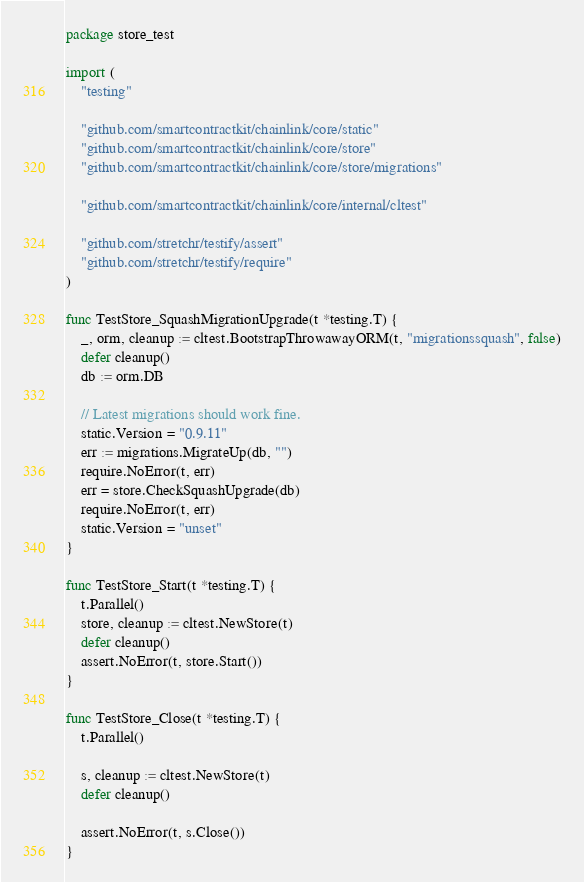Convert code to text. <code><loc_0><loc_0><loc_500><loc_500><_Go_>package store_test

import (
	"testing"

	"github.com/smartcontractkit/chainlink/core/static"
	"github.com/smartcontractkit/chainlink/core/store"
	"github.com/smartcontractkit/chainlink/core/store/migrations"

	"github.com/smartcontractkit/chainlink/core/internal/cltest"

	"github.com/stretchr/testify/assert"
	"github.com/stretchr/testify/require"
)

func TestStore_SquashMigrationUpgrade(t *testing.T) {
	_, orm, cleanup := cltest.BootstrapThrowawayORM(t, "migrationssquash", false)
	defer cleanup()
	db := orm.DB

	// Latest migrations should work fine.
	static.Version = "0.9.11"
	err := migrations.MigrateUp(db, "")
	require.NoError(t, err)
	err = store.CheckSquashUpgrade(db)
	require.NoError(t, err)
	static.Version = "unset"
}

func TestStore_Start(t *testing.T) {
	t.Parallel()
	store, cleanup := cltest.NewStore(t)
	defer cleanup()
	assert.NoError(t, store.Start())
}

func TestStore_Close(t *testing.T) {
	t.Parallel()

	s, cleanup := cltest.NewStore(t)
	defer cleanup()

	assert.NoError(t, s.Close())
}
</code> 